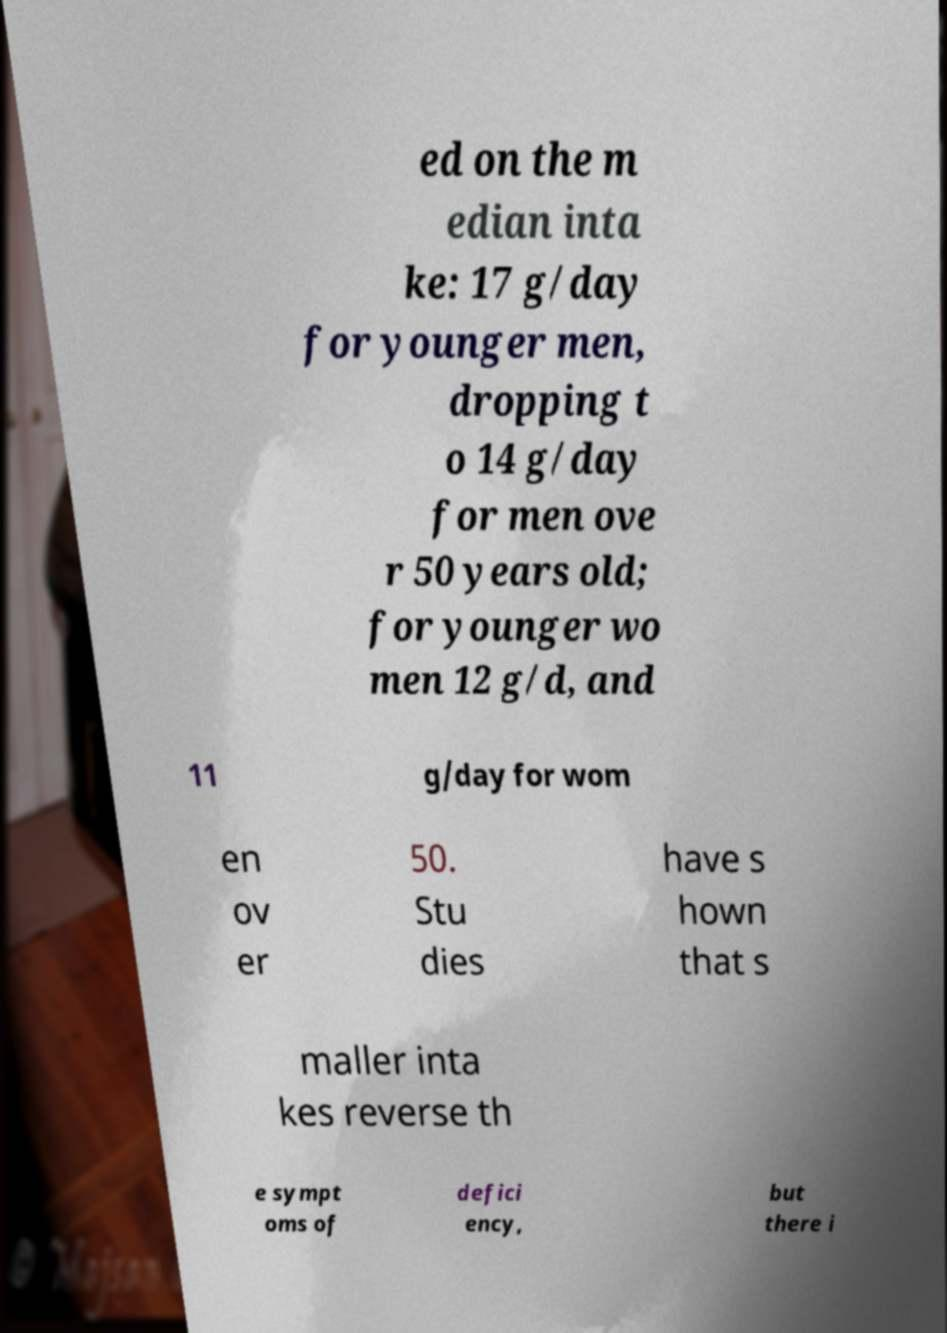Please read and relay the text visible in this image. What does it say? ed on the m edian inta ke: 17 g/day for younger men, dropping t o 14 g/day for men ove r 50 years old; for younger wo men 12 g/d, and 11 g/day for wom en ov er 50. Stu dies have s hown that s maller inta kes reverse th e sympt oms of defici ency, but there i 